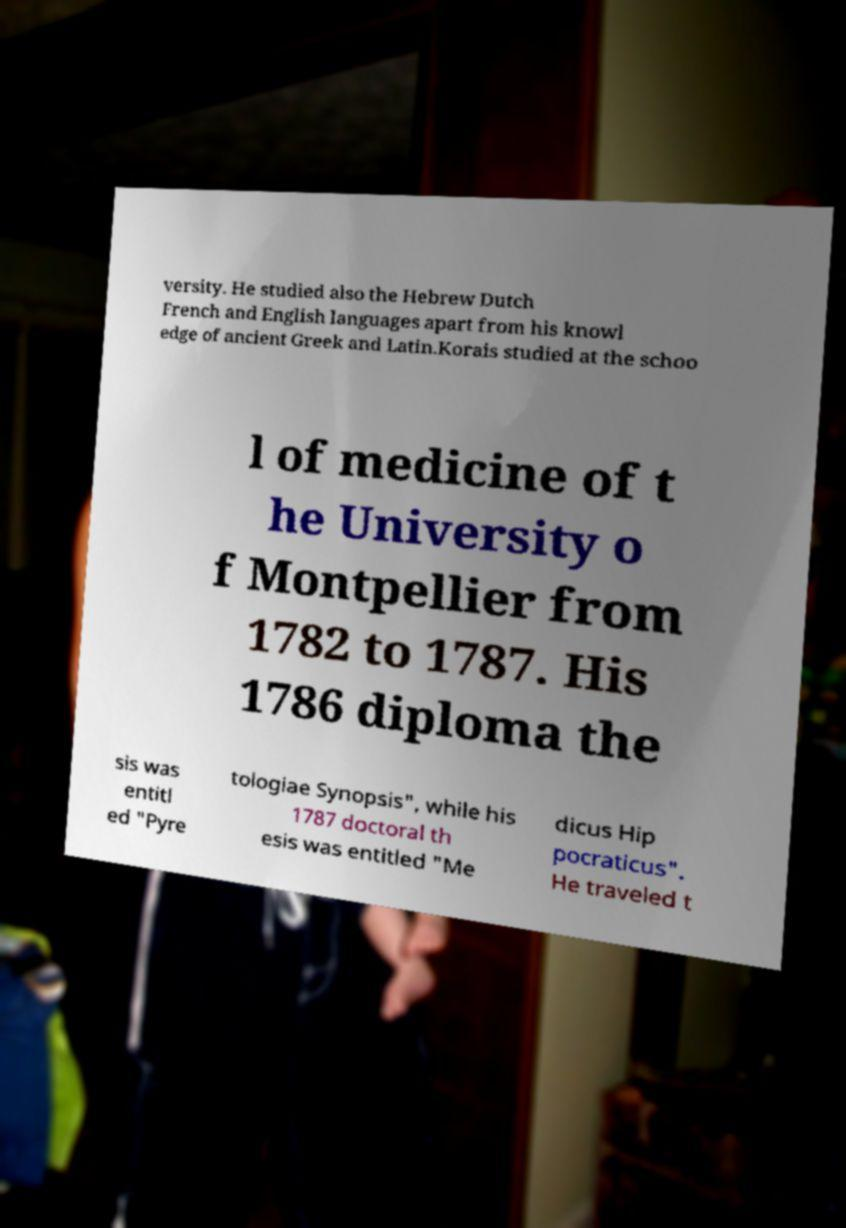Could you extract and type out the text from this image? versity. He studied also the Hebrew Dutch French and English languages apart from his knowl edge of ancient Greek and Latin.Korais studied at the schoo l of medicine of t he University o f Montpellier from 1782 to 1787. His 1786 diploma the sis was entitl ed "Pyre tologiae Synopsis", while his 1787 doctoral th esis was entitled "Me dicus Hip pocraticus". He traveled t 